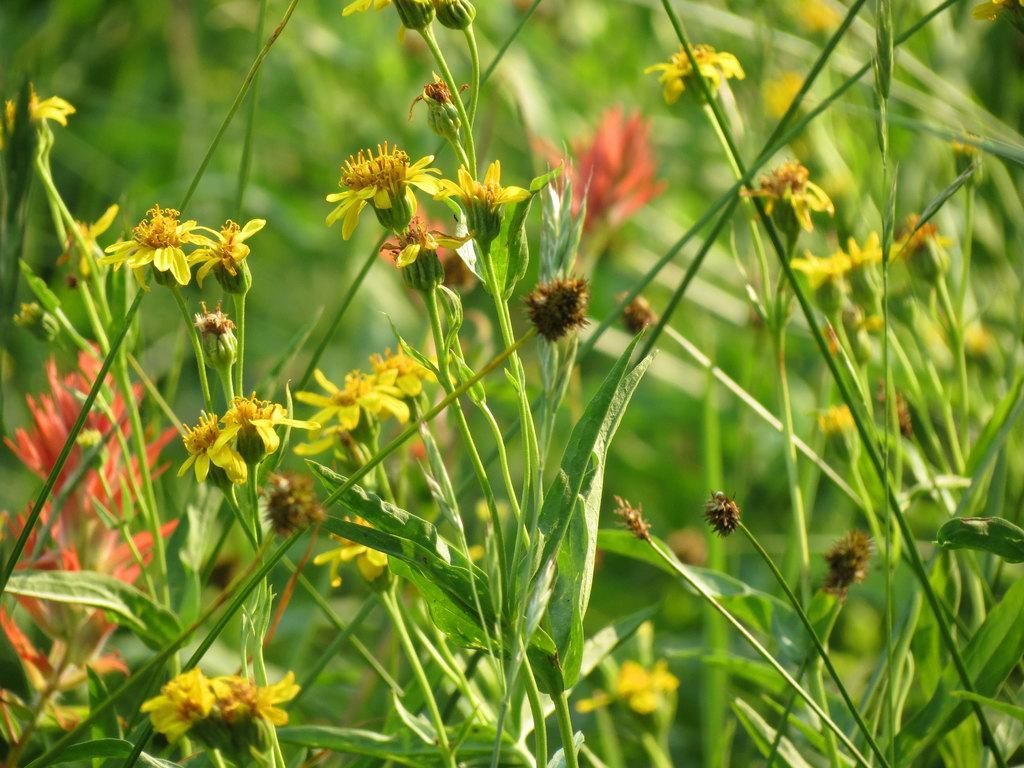Can you describe this image briefly? We can see plants and flowers. In the background it is green. 